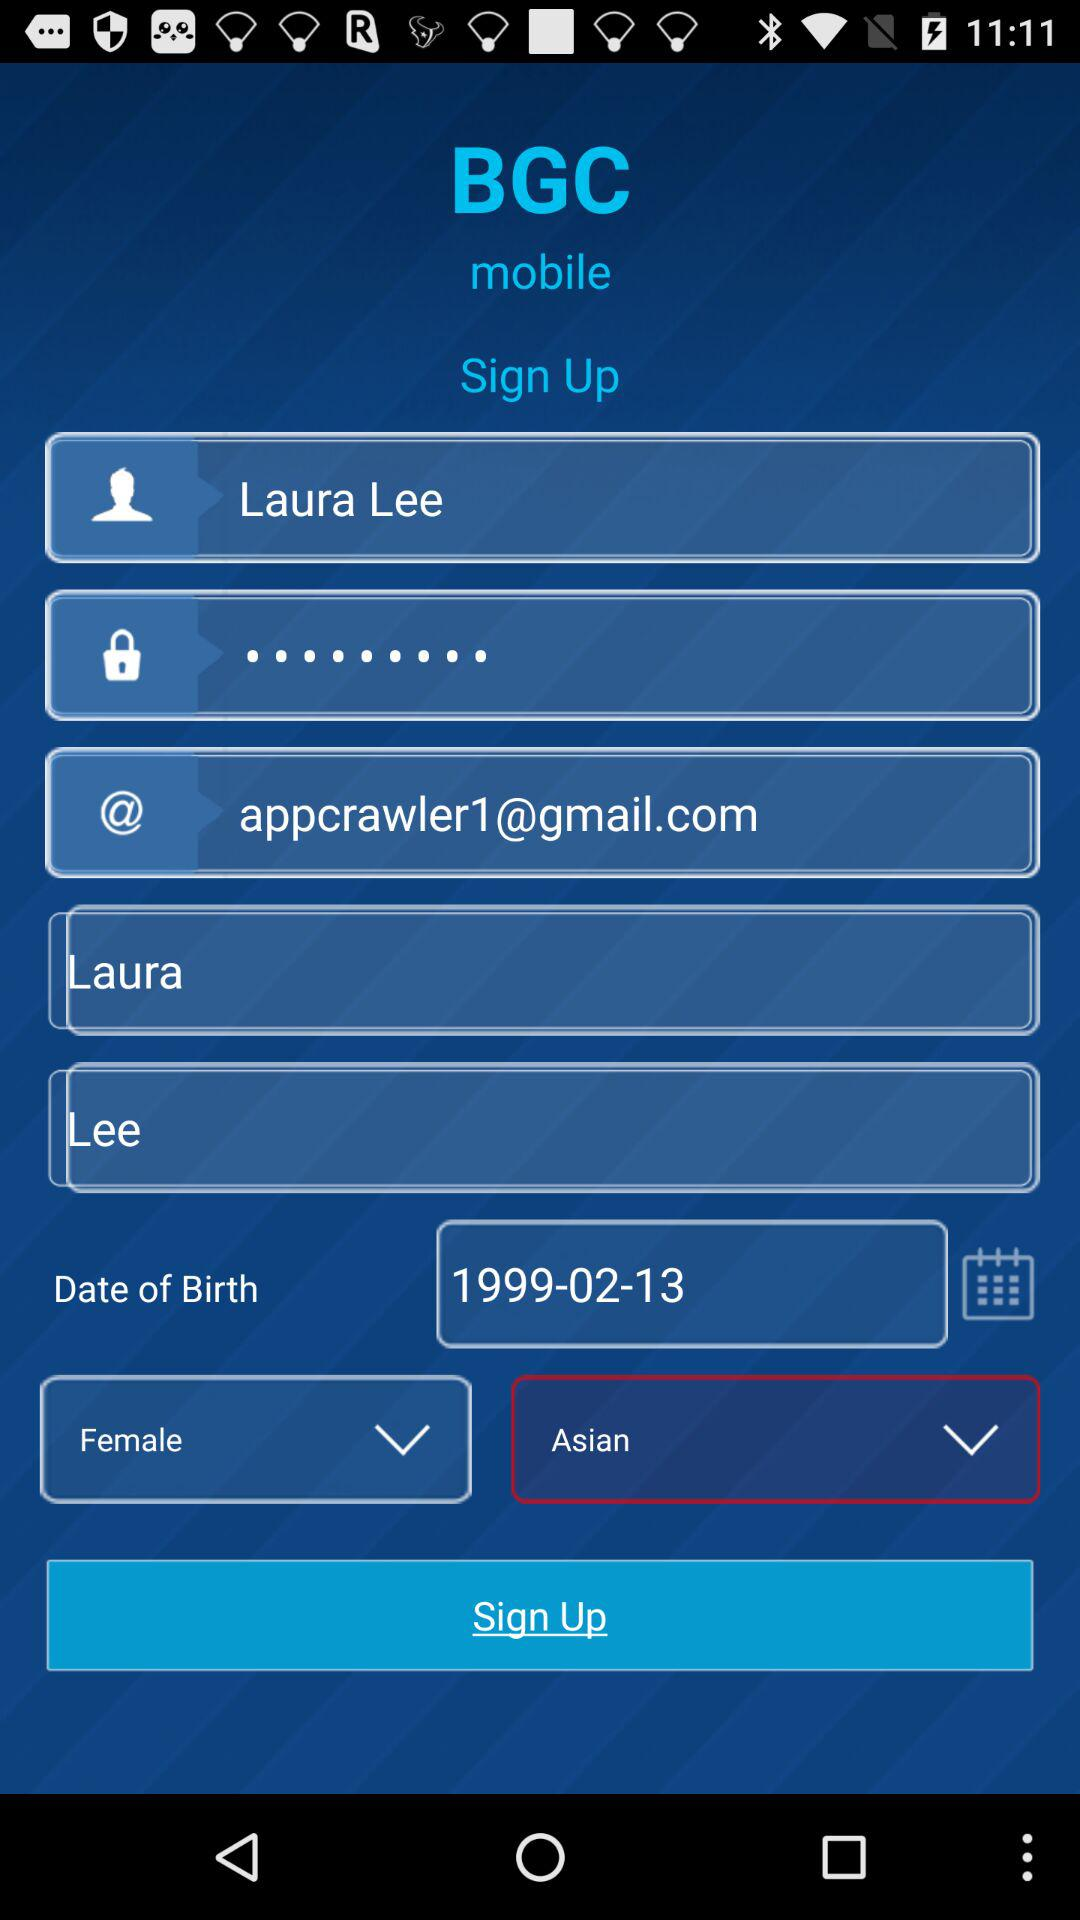What is the gender? The gender is female. 